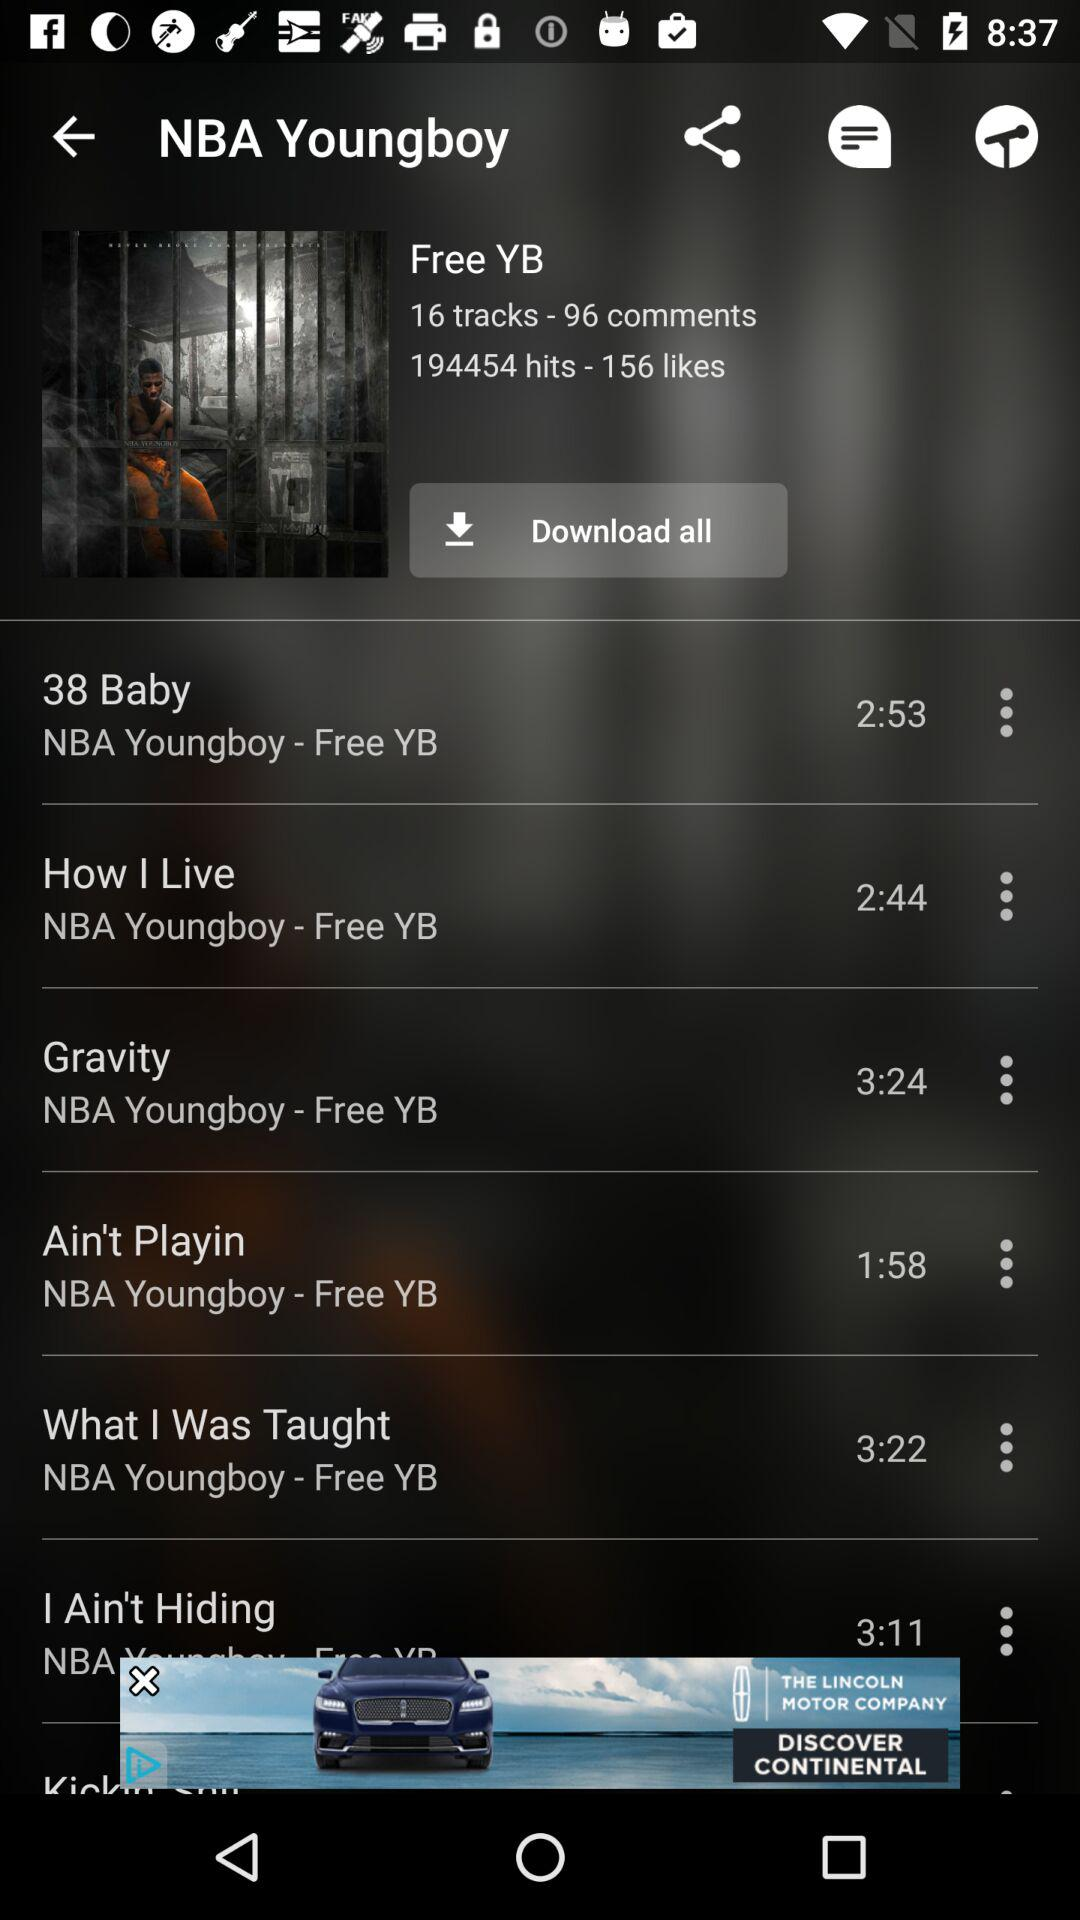What is the number of hits? The number of hits is 194454. 